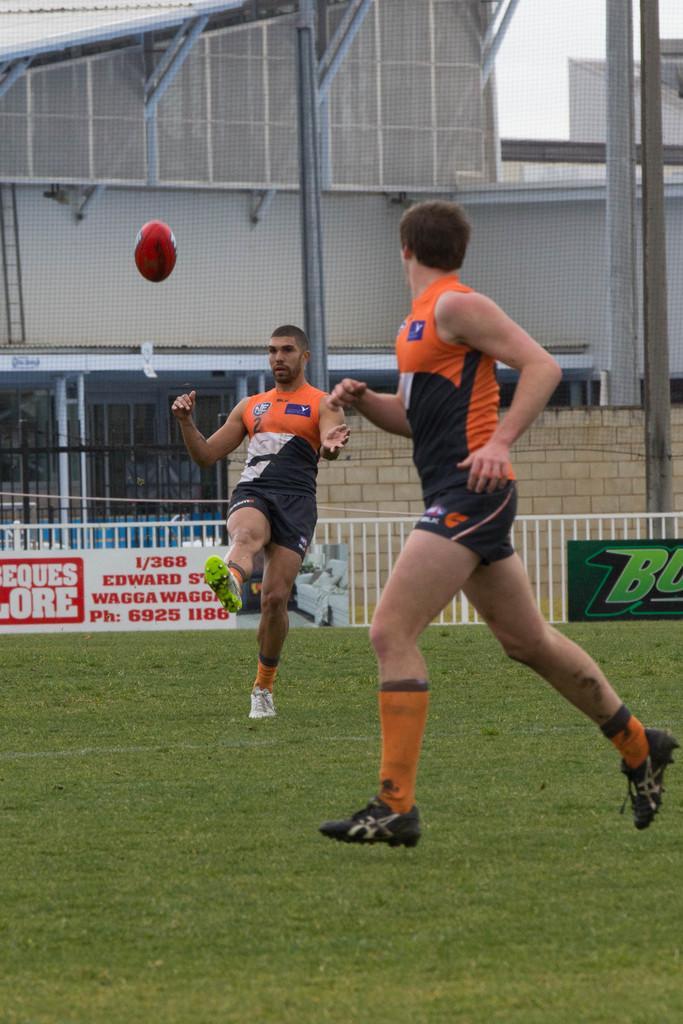Could you give a brief overview of what you see in this image? In this image we can see two persons on the ground, there is a ball, a fence, boards with text near the railing and there are buildings, a ladder and the sky in the background. 